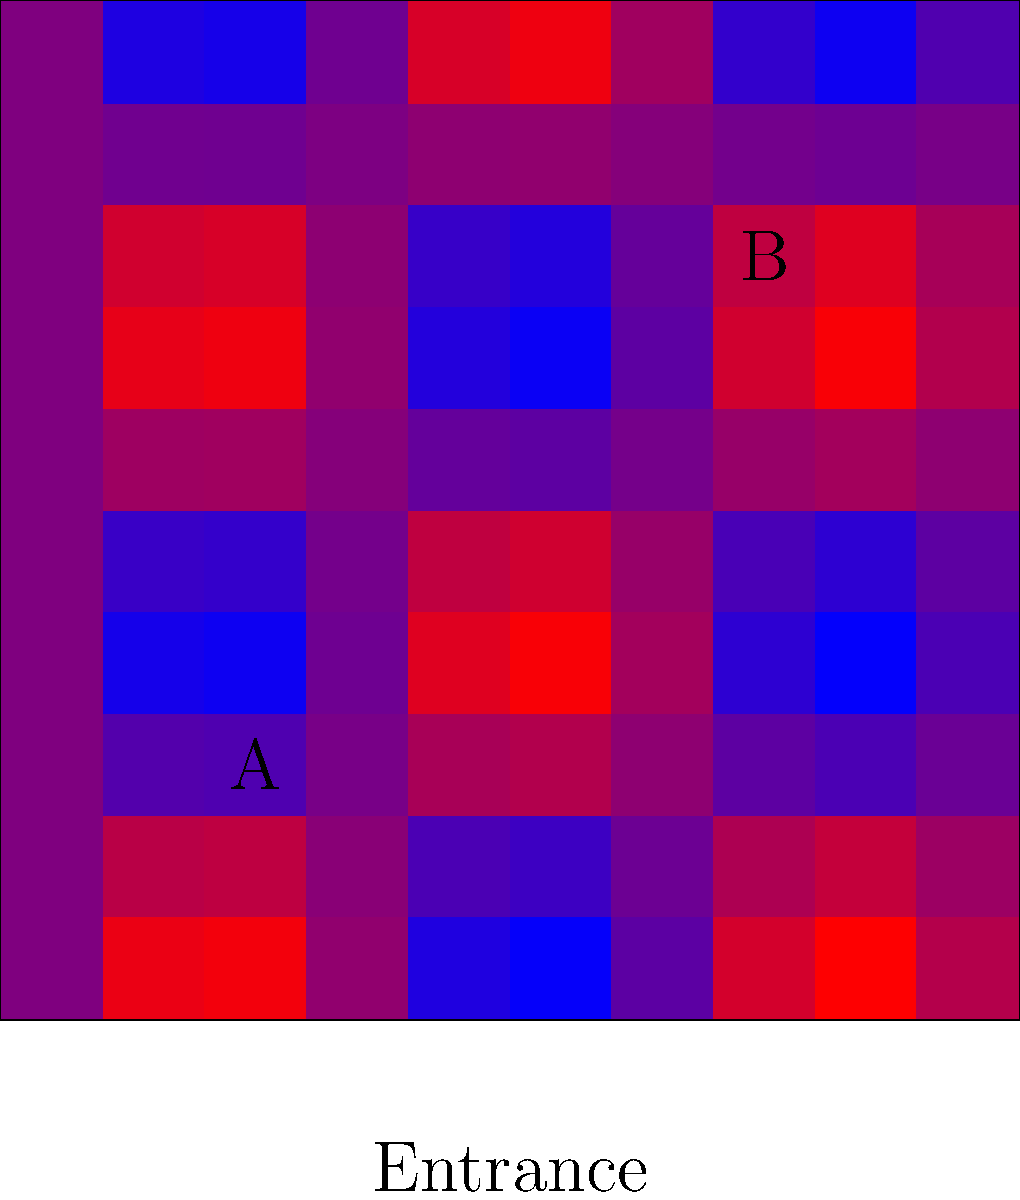As a boutique owner, you've analyzed customer movement patterns using heatmaps. The image shows two potential locations (A and B) for a new premium product display. Given that warmer colors indicate higher foot traffic, which location would you choose to maximize visibility and potential sales? Justify your answer using the concept of expected value. To determine the optimal location for the new premium product display, we need to analyze the heatmap and calculate the expected value for each location. Let's break this down step-by-step:

1. Interpret the heatmap:
   - Warmer colors (red and yellow) indicate higher foot traffic.
   - Cooler colors (green and blue) indicate lower foot traffic.

2. Analyze locations A and B:
   - Location A (25,25) is in a cooler area, indicating lower foot traffic.
   - Location B (75,75) is in a warmer area, indicating higher foot traffic.

3. Estimate foot traffic probabilities:
   - Let's assume Location A has a 30% chance of customer interaction.
   - Let's assume Location B has a 70% chance of customer interaction.

4. Estimate potential sales:
   - Assume the premium product has a value of $100.
   - For simplicity, let's say 10% of interactions lead to a sale.

5. Calculate expected value for each location:
   - Expected Value = (Probability of Interaction) × (Probability of Sale) × (Product Value)
   
   For Location A:
   $EV_A = 0.30 × 0.10 × $100 = $3$

   For Location B:
   $EV_B = 0.70 × 0.10 × $100 = $7$

6. Compare expected values:
   Location B has a higher expected value ($7 vs $3), indicating it would likely generate more sales.

Given this analysis, as a boutique owner focused on maximizing visibility and potential sales, you should choose Location B for the new premium product display.
Answer: Location B 